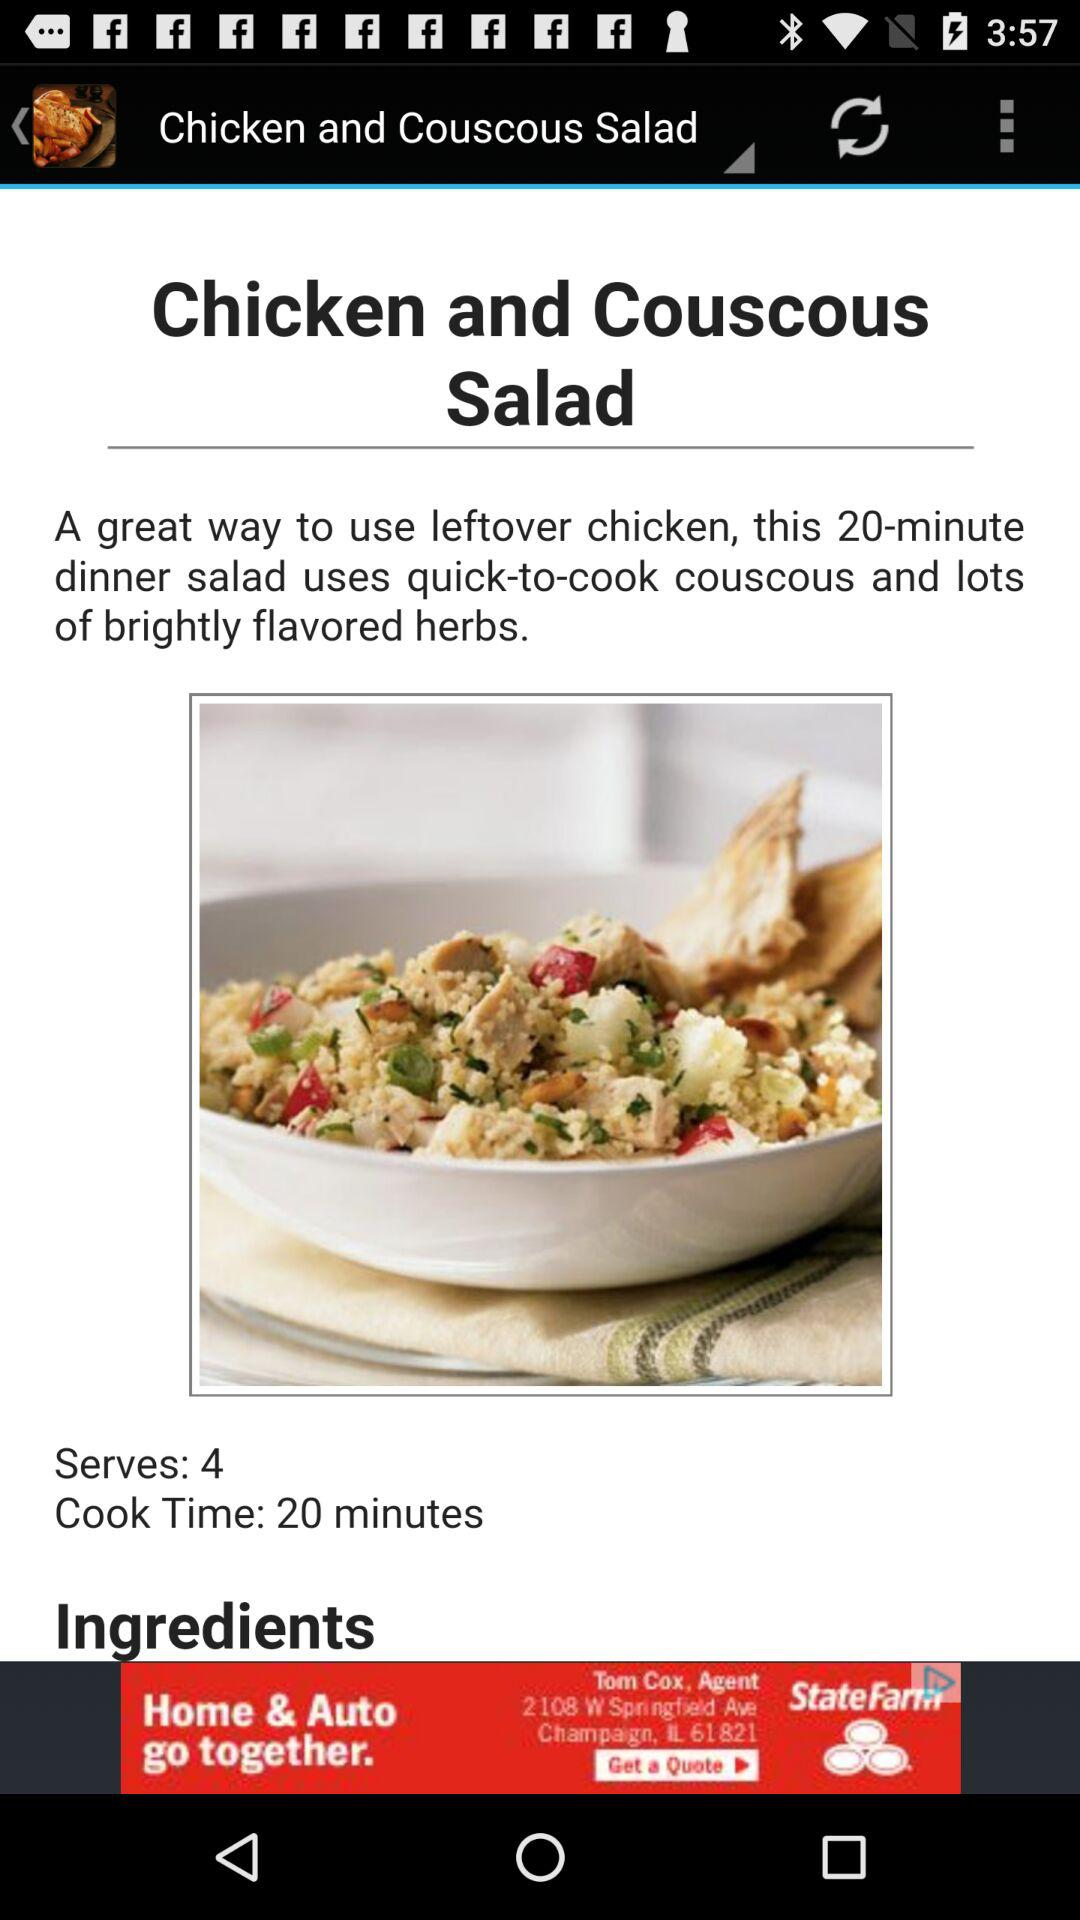What is the cooking time? The cooking time is 20 minutes. 